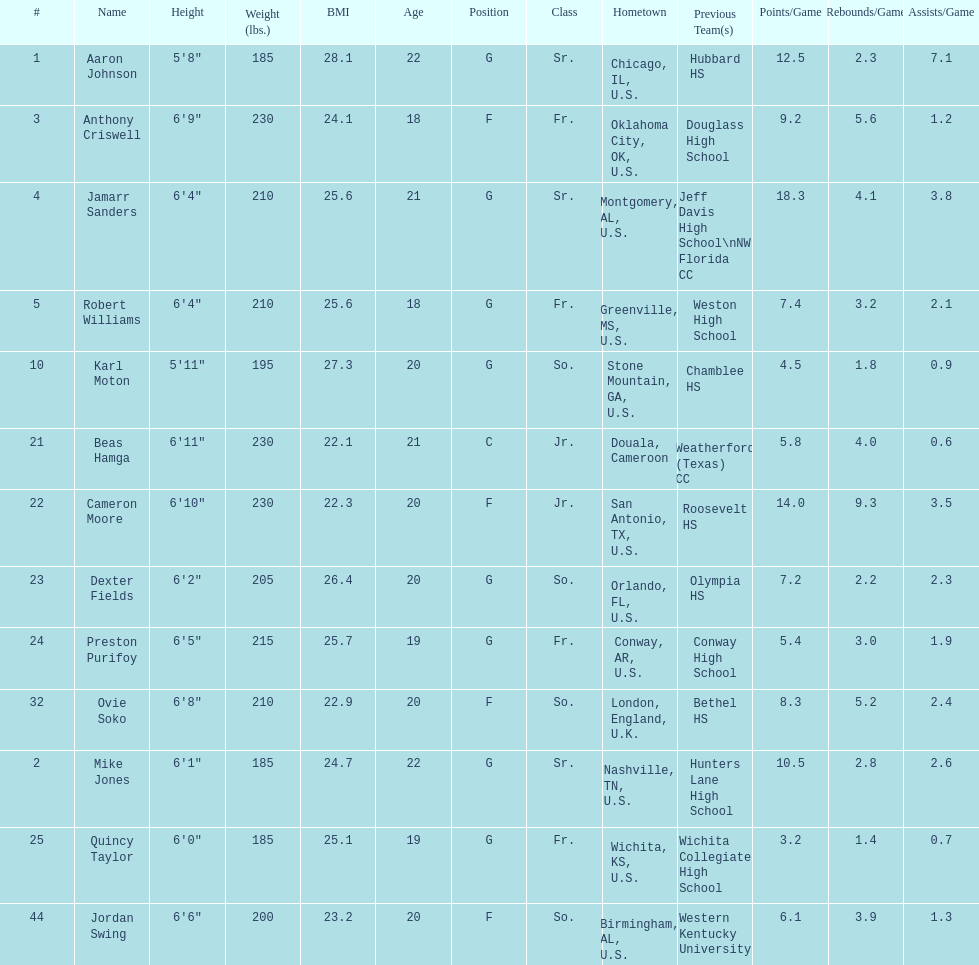Who is first on the roster? Aaron Johnson. 